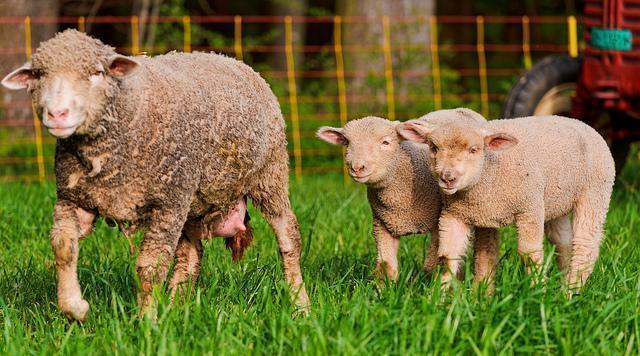How many lambs are lead by this sheep?
Make your selection from the four choices given to correctly answer the question.
Options: Three, four, two, one. Two. 